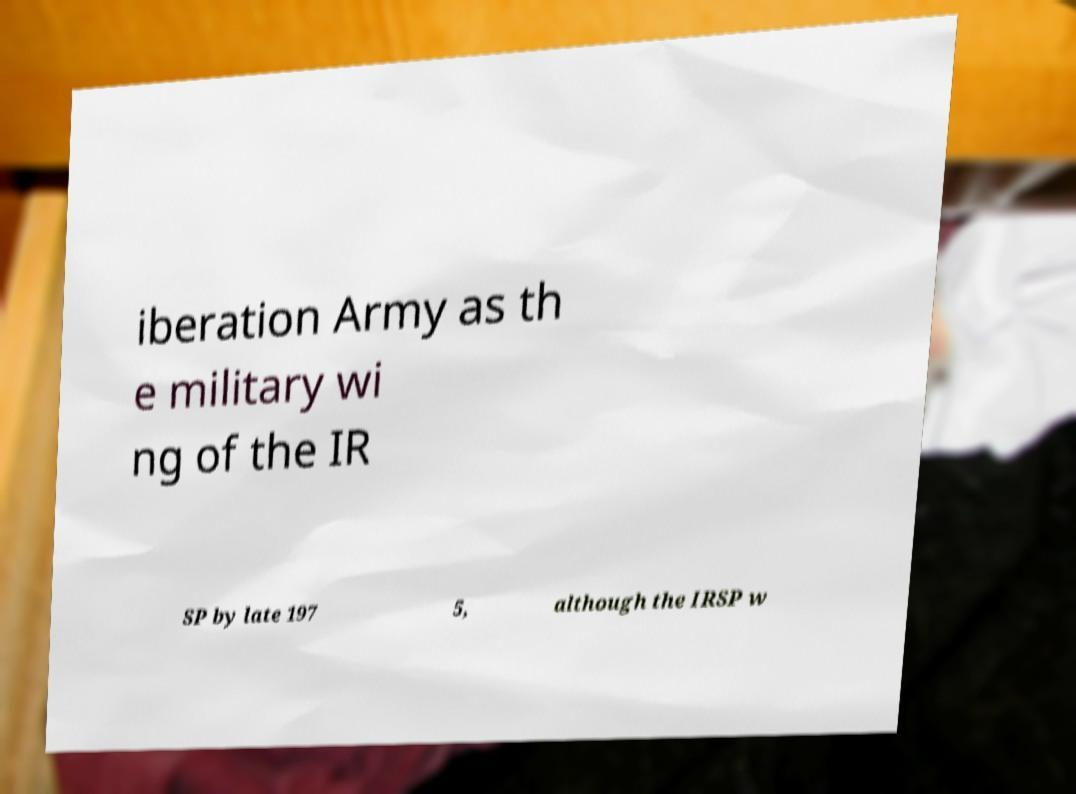Can you read and provide the text displayed in the image?This photo seems to have some interesting text. Can you extract and type it out for me? iberation Army as th e military wi ng of the IR SP by late 197 5, although the IRSP w 